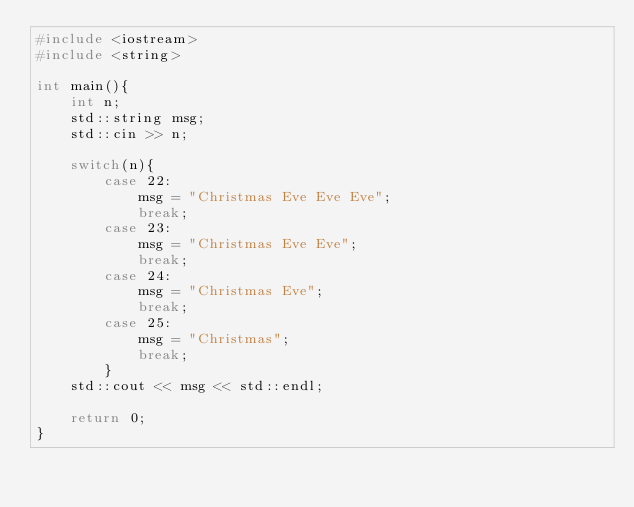<code> <loc_0><loc_0><loc_500><loc_500><_C++_>#include <iostream>
#include <string>

int main(){
	int n;
	std::string msg;
	std::cin >> n;

	switch(n){
		case 22:
			msg = "Christmas Eve Eve Eve";
			break;
		case 23:
			msg = "Christmas Eve Eve";
			break;
		case 24:
			msg = "Christmas Eve";
			break;
		case 25:
			msg = "Christmas";
			break;
		}
	std::cout << msg << std::endl;

	return 0;
}</code> 